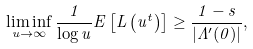Convert formula to latex. <formula><loc_0><loc_0><loc_500><loc_500>\liminf _ { u \to \infty } \frac { 1 } { \log u } { E } \left [ L \left ( u ^ { t } \right ) \right ] \geq \frac { 1 - s } { | \Lambda ^ { \prime } ( 0 ) | } ,</formula> 